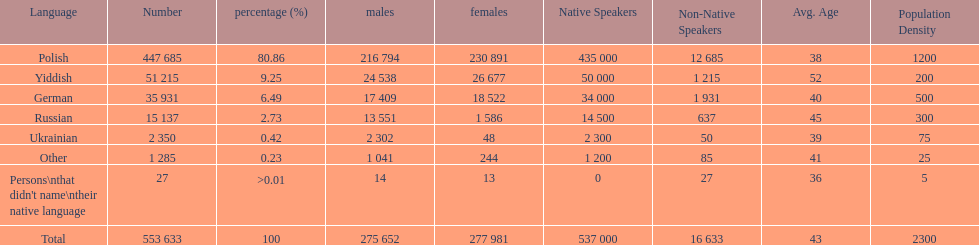Which language did only .42% of people in the imperial census of 1897 speak in the p&#322;ock governorate? Ukrainian. 